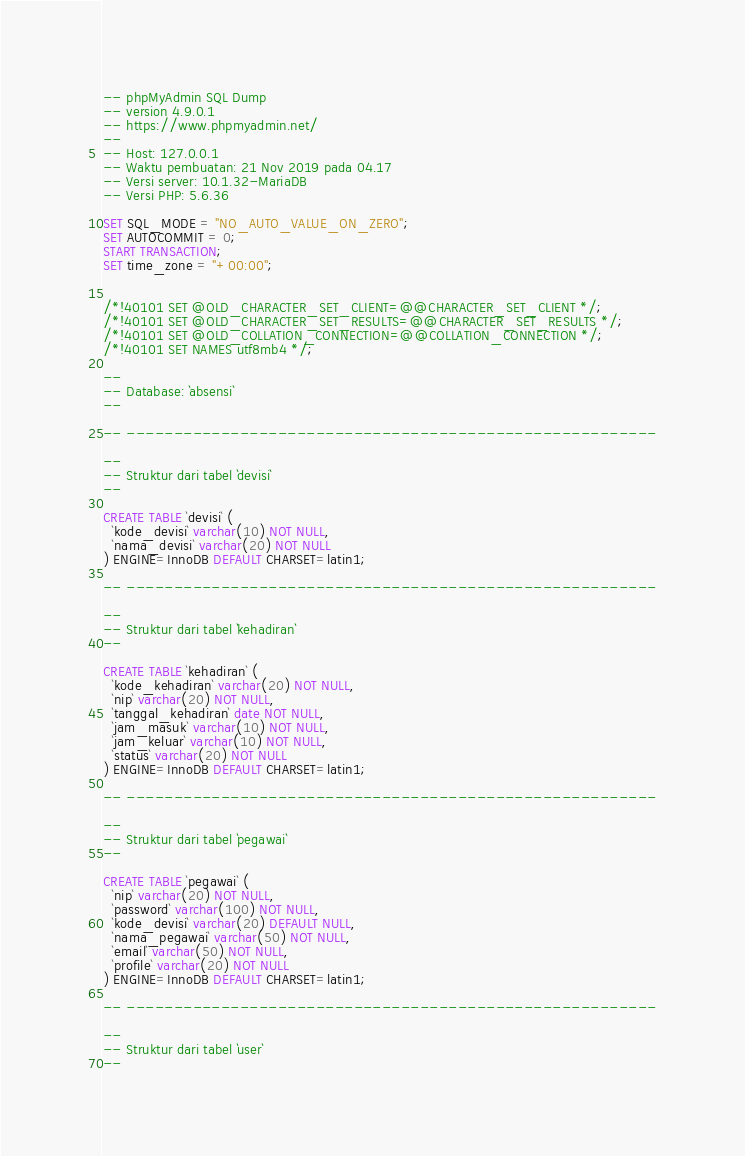<code> <loc_0><loc_0><loc_500><loc_500><_SQL_>-- phpMyAdmin SQL Dump
-- version 4.9.0.1
-- https://www.phpmyadmin.net/
--
-- Host: 127.0.0.1
-- Waktu pembuatan: 21 Nov 2019 pada 04.17
-- Versi server: 10.1.32-MariaDB
-- Versi PHP: 5.6.36

SET SQL_MODE = "NO_AUTO_VALUE_ON_ZERO";
SET AUTOCOMMIT = 0;
START TRANSACTION;
SET time_zone = "+00:00";


/*!40101 SET @OLD_CHARACTER_SET_CLIENT=@@CHARACTER_SET_CLIENT */;
/*!40101 SET @OLD_CHARACTER_SET_RESULTS=@@CHARACTER_SET_RESULTS */;
/*!40101 SET @OLD_COLLATION_CONNECTION=@@COLLATION_CONNECTION */;
/*!40101 SET NAMES utf8mb4 */;

--
-- Database: `absensi`
--

-- --------------------------------------------------------

--
-- Struktur dari tabel `devisi`
--

CREATE TABLE `devisi` (
  `kode_devisi` varchar(10) NOT NULL,
  `nama_devisi` varchar(20) NOT NULL
) ENGINE=InnoDB DEFAULT CHARSET=latin1;

-- --------------------------------------------------------

--
-- Struktur dari tabel `kehadiran`
--

CREATE TABLE `kehadiran` (
  `kode_kehadiran` varchar(20) NOT NULL,
  `nip` varchar(20) NOT NULL,
  `tanggal_kehadiran` date NOT NULL,
  `jam_masuk` varchar(10) NOT NULL,
  `jam_keluar` varchar(10) NOT NULL,
  `status` varchar(20) NOT NULL
) ENGINE=InnoDB DEFAULT CHARSET=latin1;

-- --------------------------------------------------------

--
-- Struktur dari tabel `pegawai`
--

CREATE TABLE `pegawai` (
  `nip` varchar(20) NOT NULL,
  `password` varchar(100) NOT NULL,
  `kode_devisi` varchar(20) DEFAULT NULL,
  `nama_pegawai` varchar(50) NOT NULL,
  `email` varchar(50) NOT NULL,
  `profile` varchar(20) NOT NULL
) ENGINE=InnoDB DEFAULT CHARSET=latin1;

-- --------------------------------------------------------

--
-- Struktur dari tabel `user`
--
</code> 